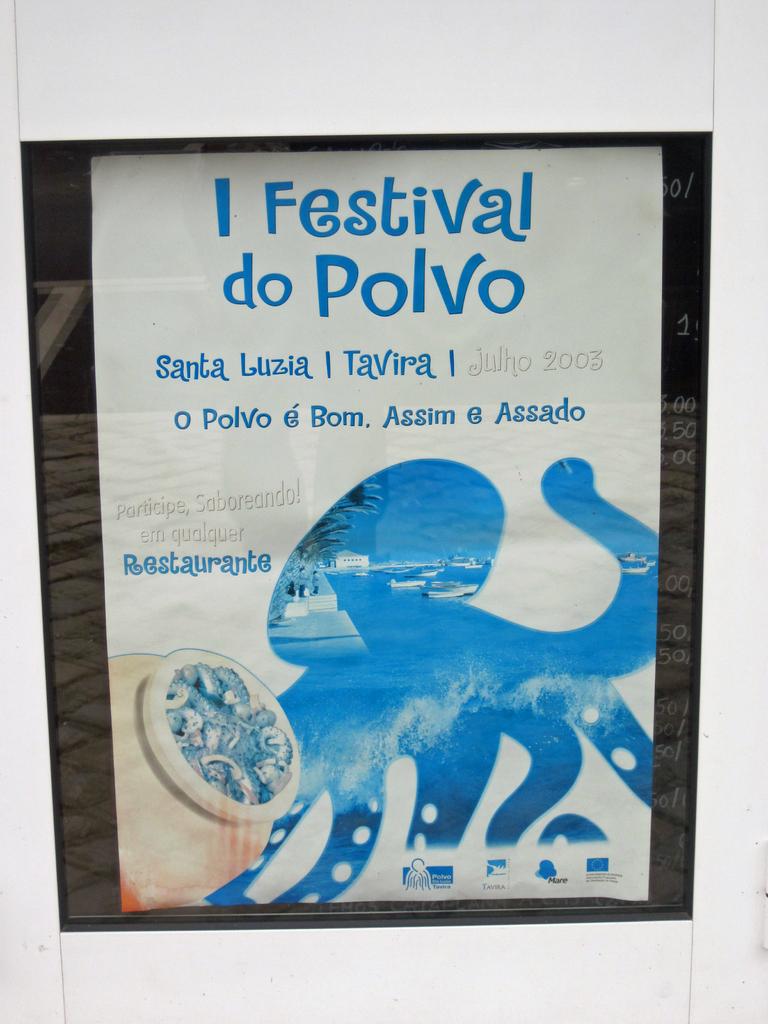Is this a festival?
Offer a terse response. Yes. 